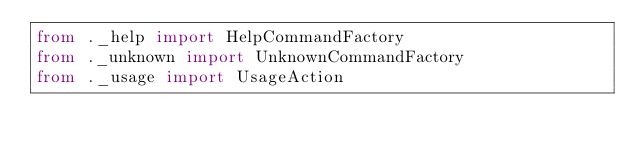Convert code to text. <code><loc_0><loc_0><loc_500><loc_500><_Python_>from ._help import HelpCommandFactory
from ._unknown import UnknownCommandFactory
from ._usage import UsageAction
</code> 